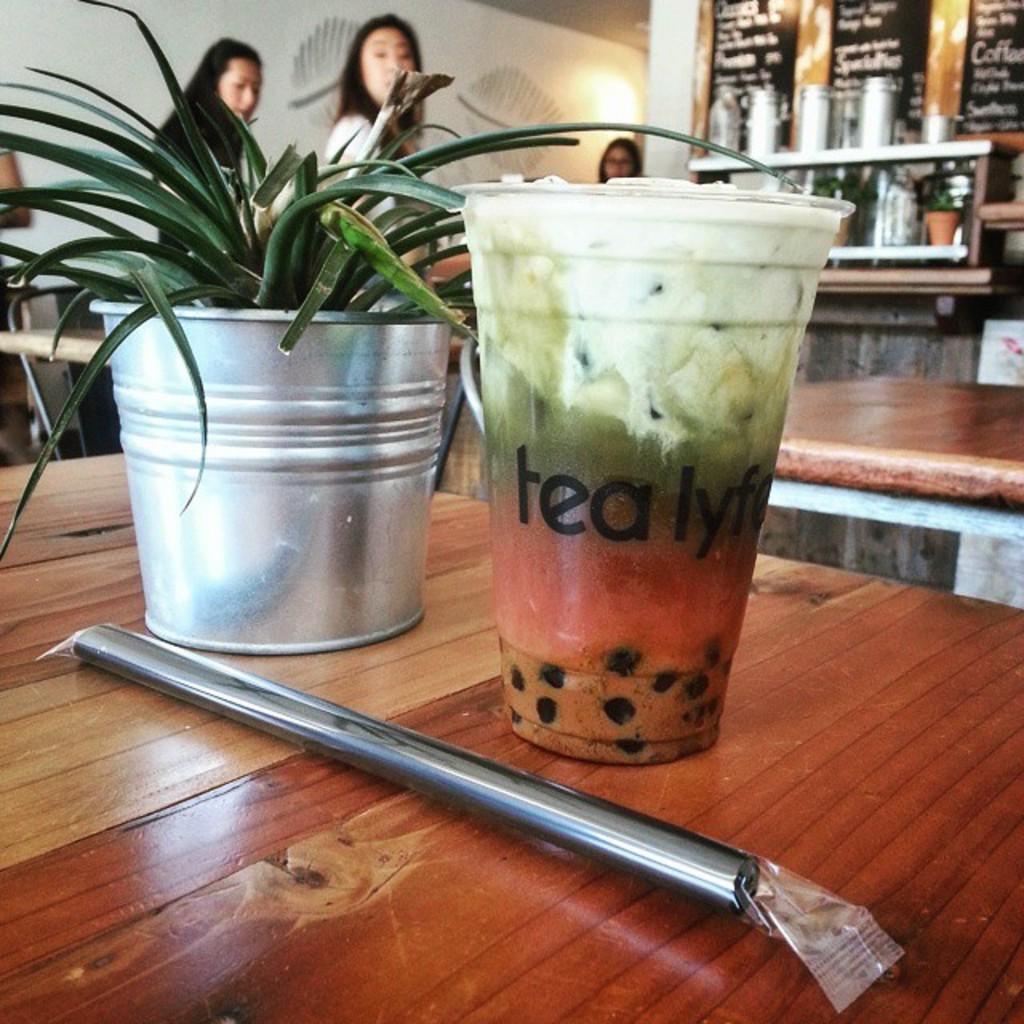Can you describe this image briefly? In the image I can see a plant pot, a glass and some other objects on a wooden surface. In the background I can see people, tables, bottles, lights, a wall and some other objects. 